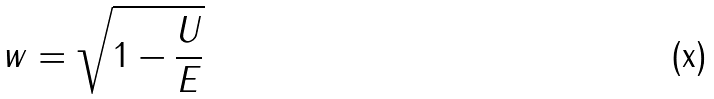<formula> <loc_0><loc_0><loc_500><loc_500>w = \sqrt { 1 - \frac { U } { E } }</formula> 